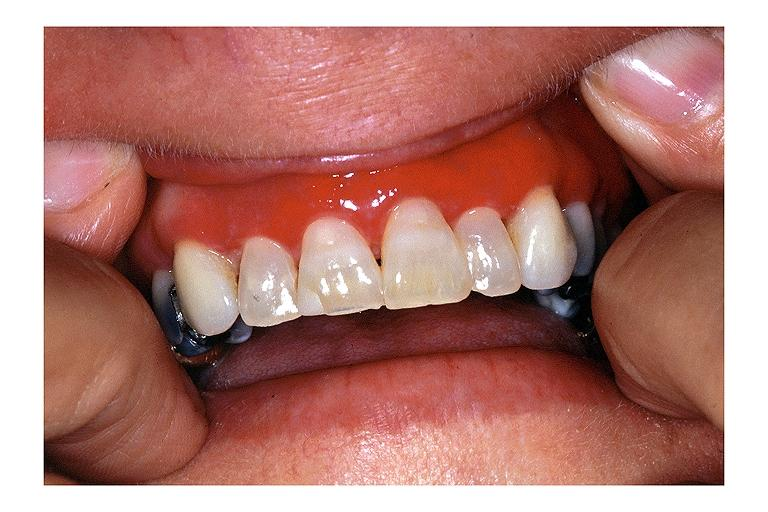does this image show desquamative gingivits?
Answer the question using a single word or phrase. Yes 